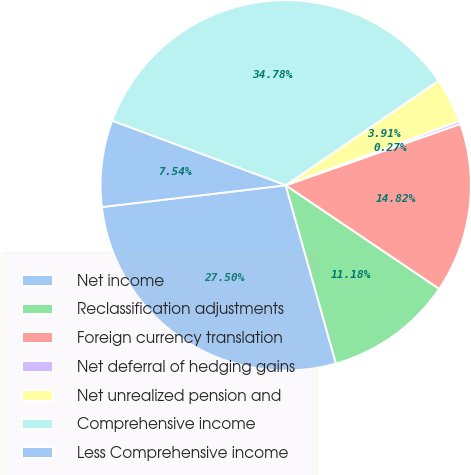<chart> <loc_0><loc_0><loc_500><loc_500><pie_chart><fcel>Net income<fcel>Reclassification adjustments<fcel>Foreign currency translation<fcel>Net deferral of hedging gains<fcel>Net unrealized pension and<fcel>Comprehensive income<fcel>Less Comprehensive income<nl><fcel>27.5%<fcel>11.18%<fcel>14.82%<fcel>0.27%<fcel>3.91%<fcel>34.78%<fcel>7.54%<nl></chart> 